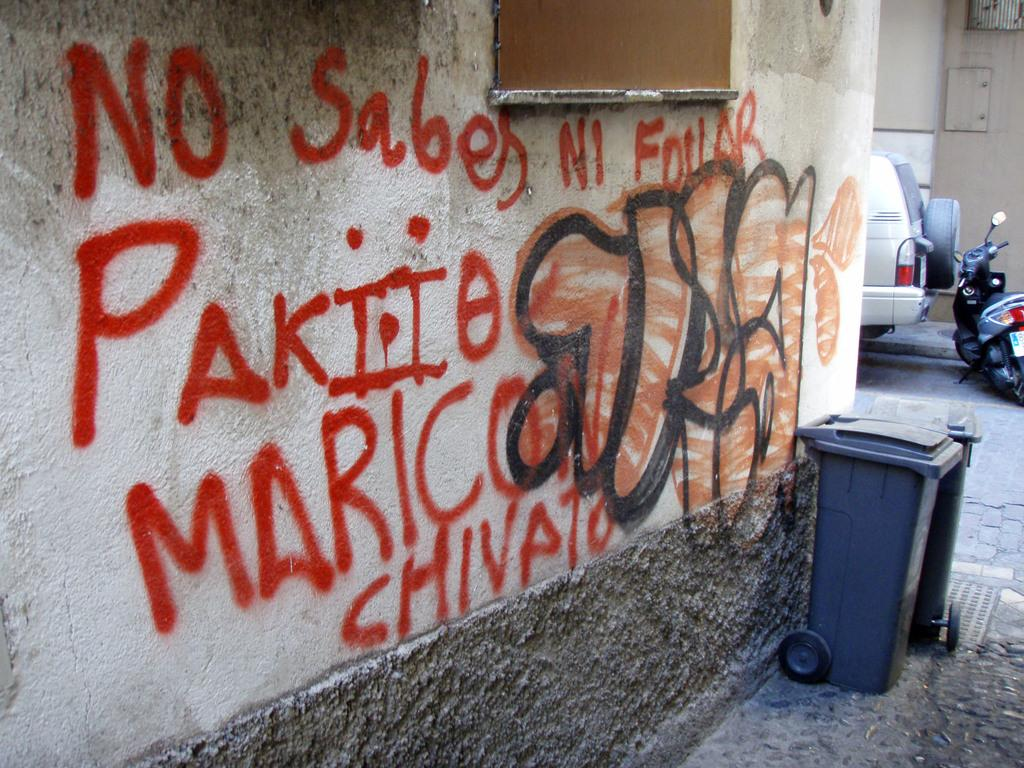<image>
Render a clear and concise summary of the photo. Someone has spray painted No Sabes on a concrete wall. 